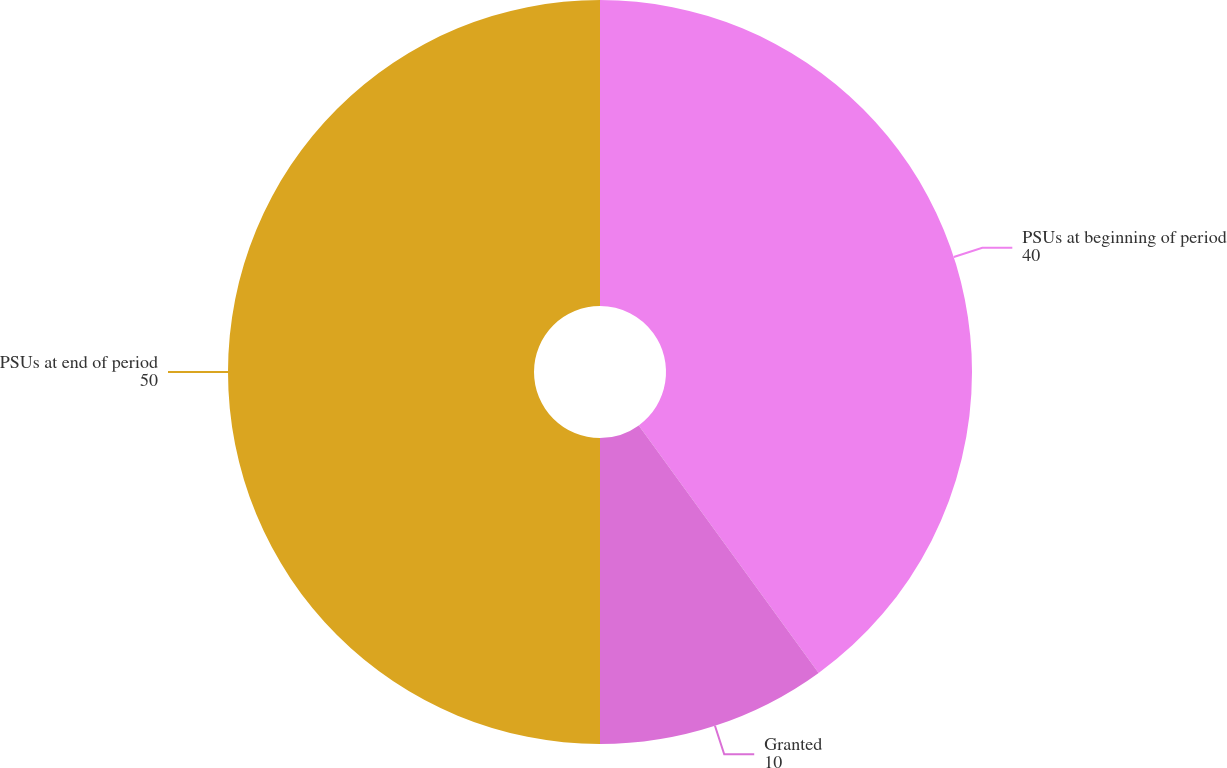Convert chart. <chart><loc_0><loc_0><loc_500><loc_500><pie_chart><fcel>PSUs at beginning of period<fcel>Granted<fcel>PSUs at end of period<nl><fcel>40.0%<fcel>10.0%<fcel>50.0%<nl></chart> 